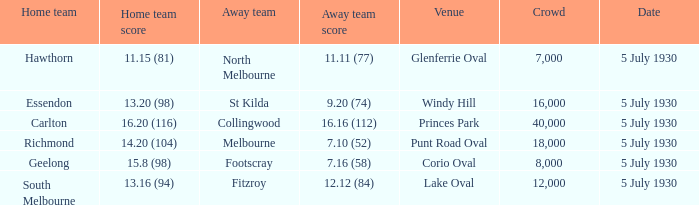Who is the guest team at corio oval? Footscray. 